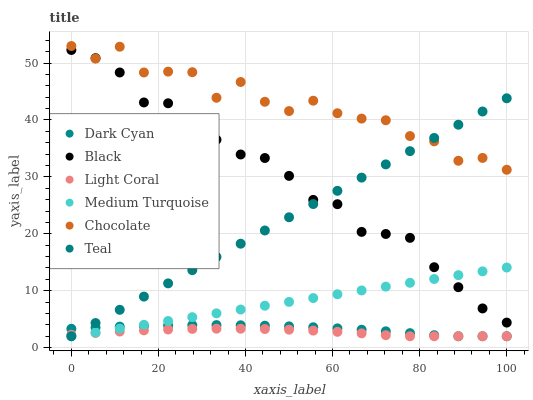Does Light Coral have the minimum area under the curve?
Answer yes or no. Yes. Does Chocolate have the maximum area under the curve?
Answer yes or no. Yes. Does Chocolate have the minimum area under the curve?
Answer yes or no. No. Does Light Coral have the maximum area under the curve?
Answer yes or no. No. Is Medium Turquoise the smoothest?
Answer yes or no. Yes. Is Chocolate the roughest?
Answer yes or no. Yes. Is Light Coral the smoothest?
Answer yes or no. No. Is Light Coral the roughest?
Answer yes or no. No. Does Medium Turquoise have the lowest value?
Answer yes or no. Yes. Does Chocolate have the lowest value?
Answer yes or no. No. Does Chocolate have the highest value?
Answer yes or no. Yes. Does Light Coral have the highest value?
Answer yes or no. No. Is Light Coral less than Chocolate?
Answer yes or no. Yes. Is Black greater than Dark Cyan?
Answer yes or no. Yes. Does Dark Cyan intersect Medium Turquoise?
Answer yes or no. Yes. Is Dark Cyan less than Medium Turquoise?
Answer yes or no. No. Is Dark Cyan greater than Medium Turquoise?
Answer yes or no. No. Does Light Coral intersect Chocolate?
Answer yes or no. No. 